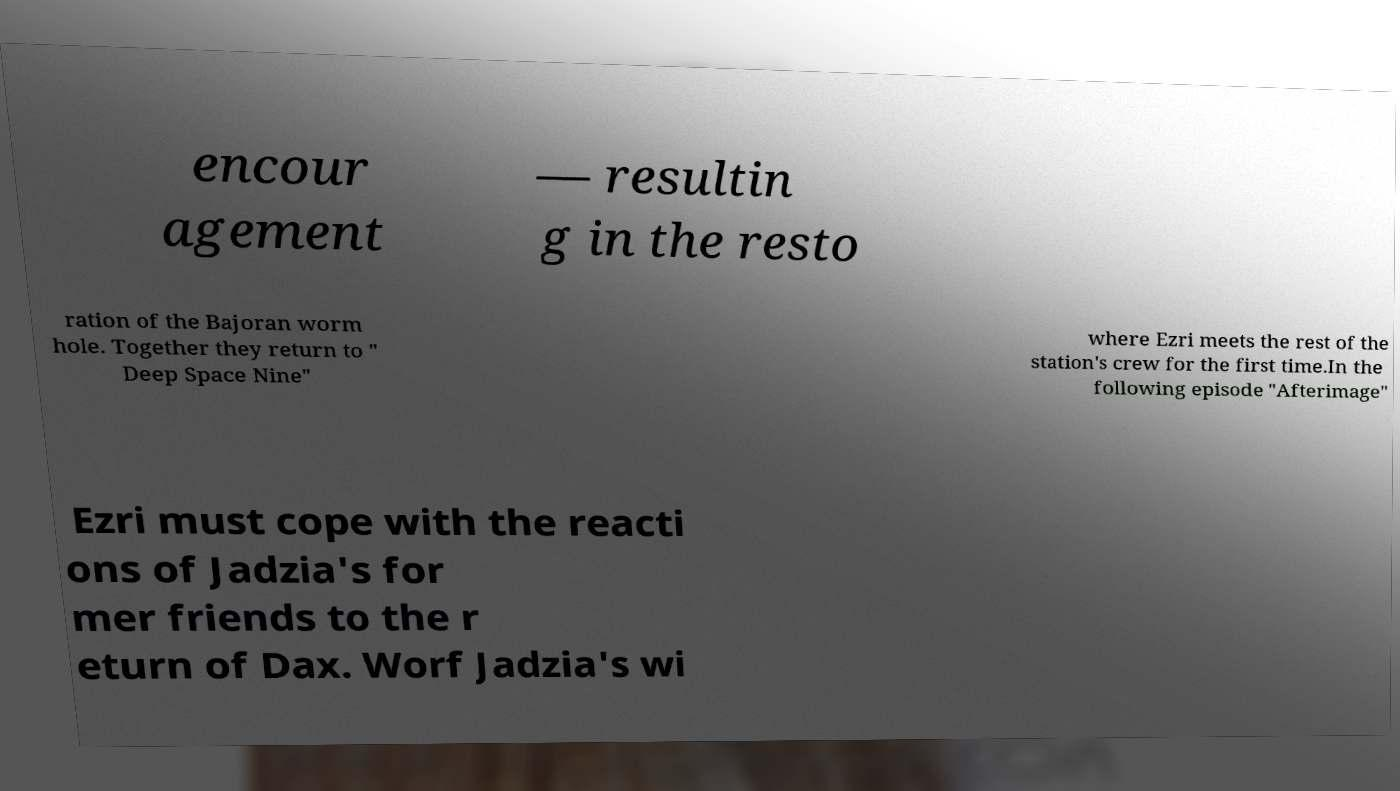For documentation purposes, I need the text within this image transcribed. Could you provide that? encour agement — resultin g in the resto ration of the Bajoran worm hole. Together they return to " Deep Space Nine" where Ezri meets the rest of the station's crew for the first time.In the following episode "Afterimage" Ezri must cope with the reacti ons of Jadzia's for mer friends to the r eturn of Dax. Worf Jadzia's wi 